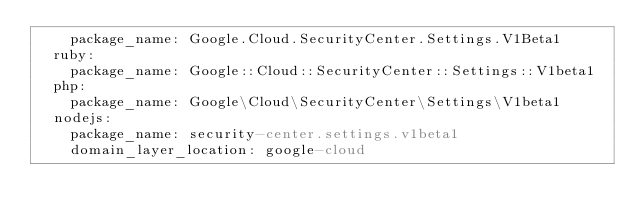<code> <loc_0><loc_0><loc_500><loc_500><_YAML_>    package_name: Google.Cloud.SecurityCenter.Settings.V1Beta1
  ruby:
    package_name: Google::Cloud::SecurityCenter::Settings::V1beta1
  php:
    package_name: Google\Cloud\SecurityCenter\Settings\V1beta1
  nodejs:
    package_name: security-center.settings.v1beta1
    domain_layer_location: google-cloud
</code> 